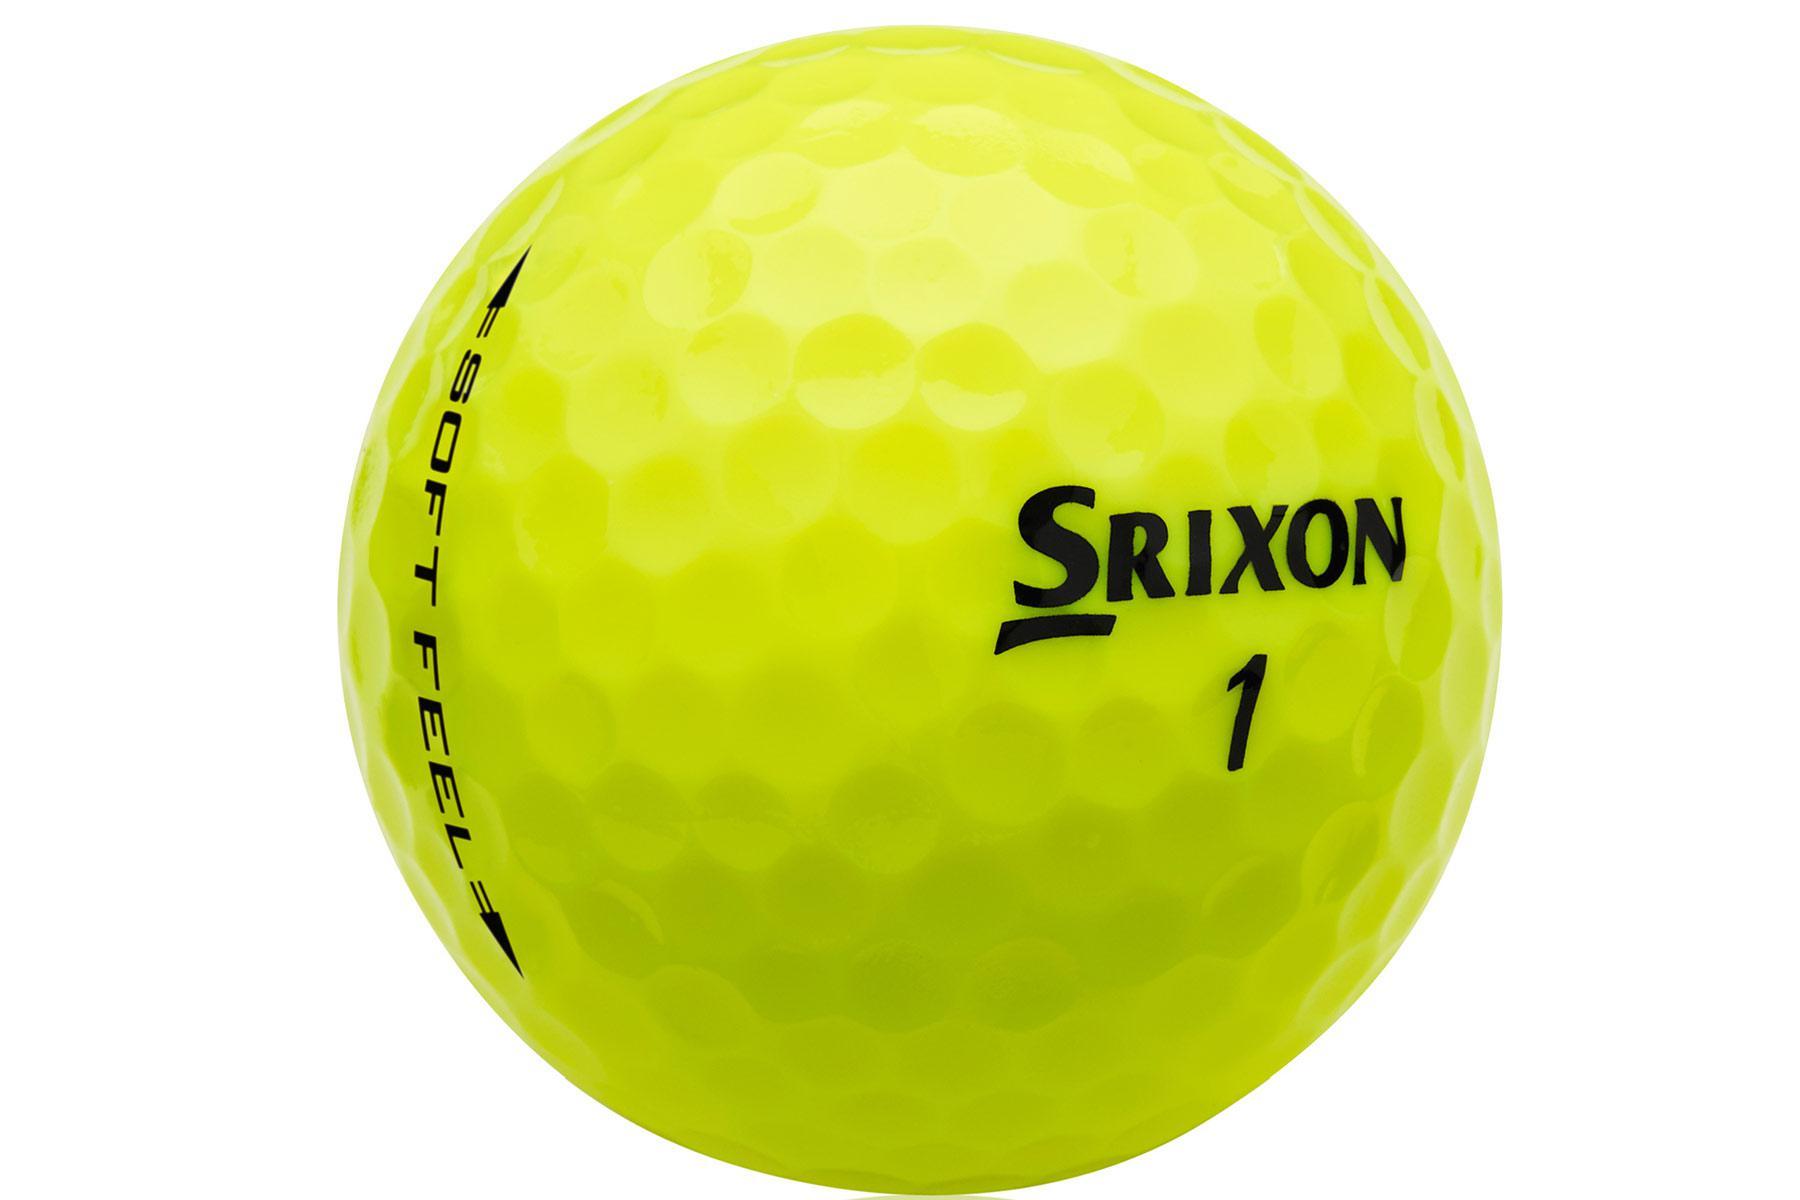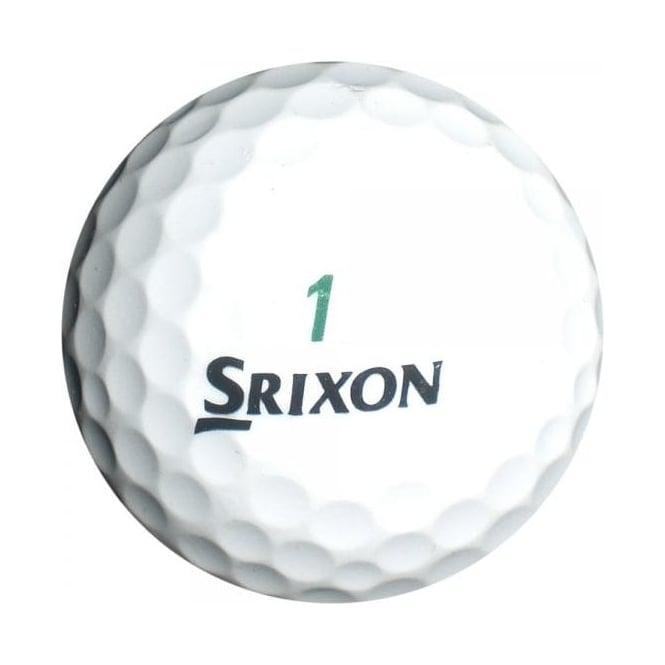The first image is the image on the left, the second image is the image on the right. Analyze the images presented: Is the assertion "The object in the image on the left is mostly green." valid? Answer yes or no. Yes. 